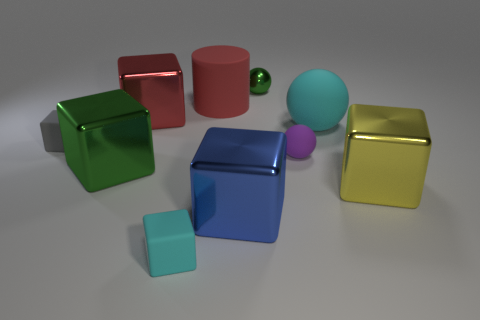Subtract all cyan rubber spheres. How many spheres are left? 2 Subtract all green spheres. How many spheres are left? 2 Subtract all spheres. How many objects are left? 7 Subtract 1 cyan balls. How many objects are left? 9 Subtract 1 balls. How many balls are left? 2 Subtract all red blocks. Subtract all cyan balls. How many blocks are left? 5 Subtract all brown cylinders. How many green cubes are left? 1 Subtract all big matte cylinders. Subtract all large cyan rubber things. How many objects are left? 8 Add 2 tiny rubber cubes. How many tiny rubber cubes are left? 4 Add 3 big cyan things. How many big cyan things exist? 4 